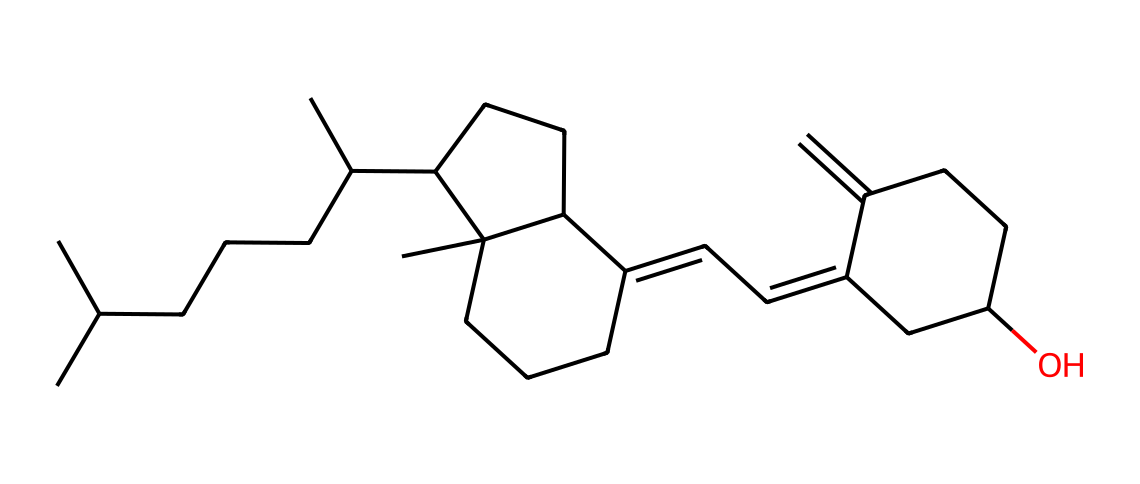What is the main function of Vitamin D? Vitamin D plays a crucial role in calcium absorption, which is essential for maintaining bone health. Its structure enables it to interact effectively with vitamin D receptors in the intestines, promoting the uptake of calcium from the diet.
Answer: calcium absorption How many carbon atoms are present in this molecule? By analyzing the SMILES representation, I can count the number of carbon atoms directly; in this case, there are 27 carbon atoms present in the structure.
Answer: 27 What type of compound is represented by this structure? The chemical structure corresponds to a fat-soluble vitamin, categorized under steroids due to its four-ring structure and the presence of a secosteroid configuration.
Answer: steroid Does this molecule contain double bonds? Yes, the rendered chemical structure has double bonds present, as indicated by the 'C=C' notations in the SMILES representation, showcasing unsaturation.
Answer: yes What is the impact of Vitamin D deficiency on bone health? Vitamin D deficiency can lead to insufficient calcium absorption, which may cause bone weakening, increased risk of fractures, and conditions like rickets in children and osteomalacia in adults.
Answer: bone weakening How does the presence of hydroxyl groups affect Vitamin D's function? Hydroxyl groups enhance the solubility of Vitamin D in aqueous environments, allowing it to exert its biological functions more effectively, particularly in calcium metabolism and hormone regulation.
Answer: increases solubility 